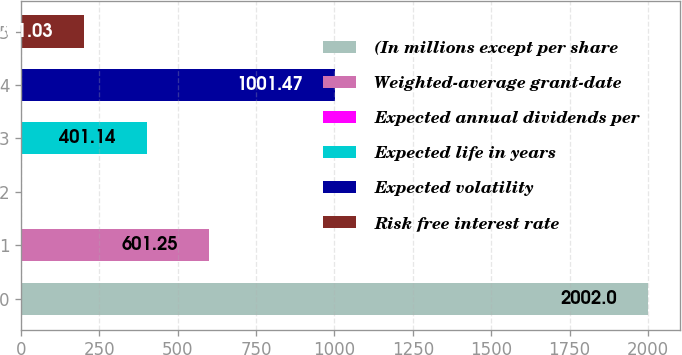Convert chart. <chart><loc_0><loc_0><loc_500><loc_500><bar_chart><fcel>(In millions except per share<fcel>Weighted-average grant-date<fcel>Expected annual dividends per<fcel>Expected life in years<fcel>Expected volatility<fcel>Risk free interest rate<nl><fcel>2002<fcel>601.25<fcel>0.92<fcel>401.14<fcel>1001.47<fcel>201.03<nl></chart> 